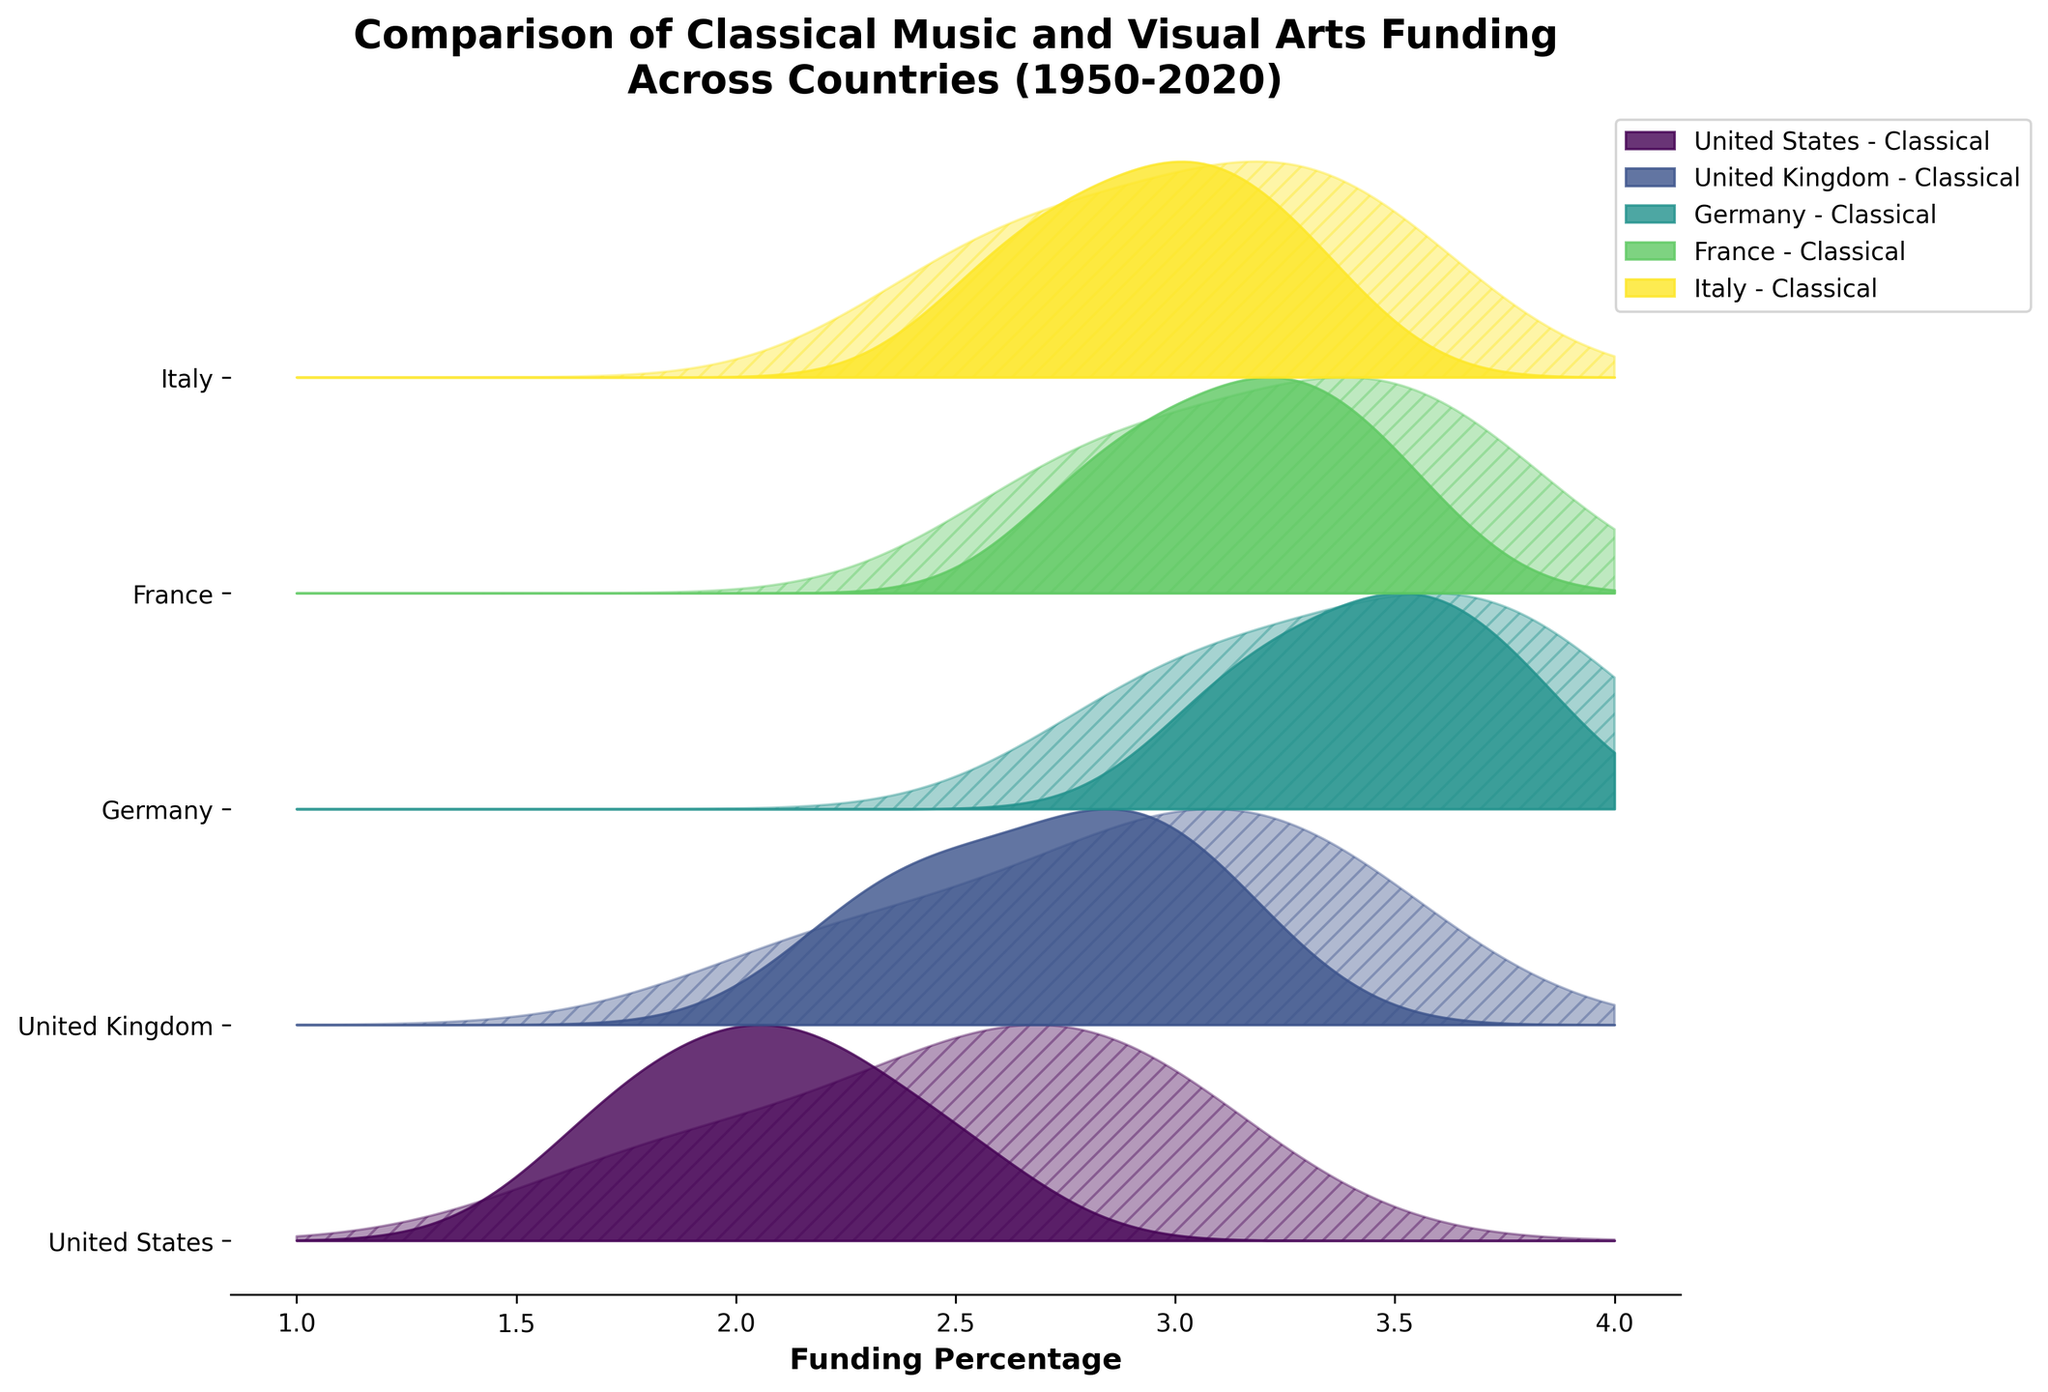What countries are included in the plot? The plot includes multiple lines or ridges, each corresponding to a different country. Examining the labels on the y-axis shows the list of countries.
Answer: United States, United Kingdom, Germany, France, Italy Which country shows the highest funding for classical music programs in 2020? To find this, look at the ridges labeled by country and 2020 on the x-axis, checking for the peak value of classical music funding.
Answer: Germany How has visual arts funding in the United States changed from 1950 to 2020? Check the United States section and compare the height of the ridges for visual arts funding between 1950 and 2020.
Answer: Increased Which funding type (classical music or visual arts) has generally increased more across all countries from 1950 to 2020? Comparing the height changes of ridges for both funding types across different countries from 1950 to 2020 will answer this.
Answer: Visual Arts In which country did classical music funding peak, and around which year? Look for the highest point across all ridges labeled 'Classical' and check the corresponding country and year.
Answer: Germany, in 1970 What is the general trend in classical music funding in the United Kingdom from 1950 to 2020? Observe the change in height of the 'Classical' ridges for the United Kingdom from 1950 to 2020.
Answer: Decreasing Which country shows the smallest difference between the peak funding levels for classical music and visual arts in 2020? Compare the peak heights of both funding types for each country in the year 2020.
Answer: France How does Italy's classical music funding in 1990 compare to its visual arts funding in the same year? Look at the height of the ridges for Italy in 1990 and compare the ridges labeled 'Classical' and 'Visual'.
Answer: Classical music funding is slightly higher What color represents Germany’s classical music funding in the plot? Check the colors used in the ridgeline plot to identify the consistent color correlated with different country ridges for classical music.
Answer: Specific color depending on the colormap used (e.g., a shade from the viridis colormap) What change can be inferred for Germany’s visual arts funding between 1950 and 2020? Observe the visual arts funding ridge heights for Germany between 1950 and 2020 to determine the change.
Answer: Increase 